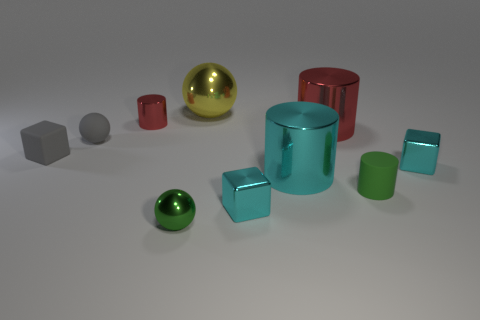There is a small thing behind the gray matte sphere; what material is it? The small object behind the gray matte sphere appears to be made of glass, identifiable by its transparent and reflective surface. 